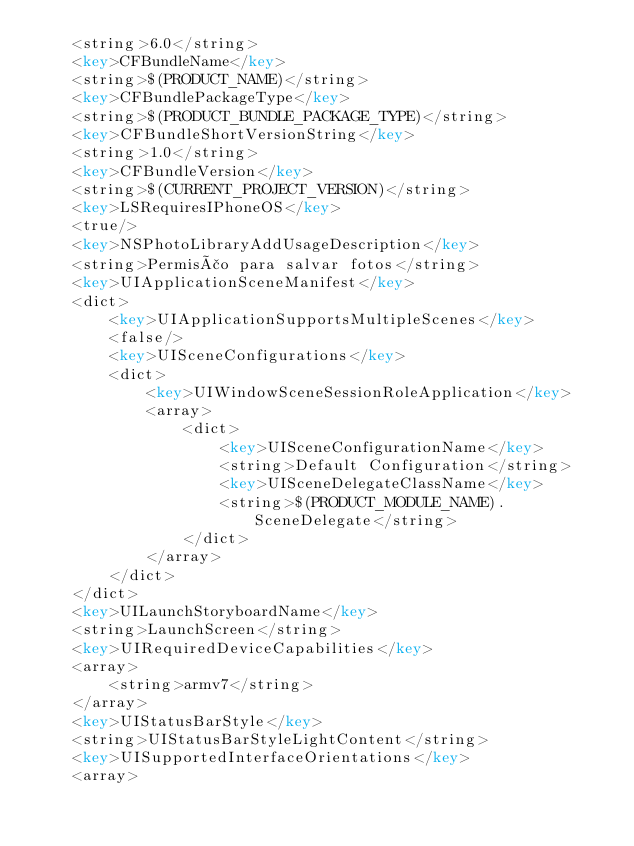<code> <loc_0><loc_0><loc_500><loc_500><_XML_>	<string>6.0</string>
	<key>CFBundleName</key>
	<string>$(PRODUCT_NAME)</string>
	<key>CFBundlePackageType</key>
	<string>$(PRODUCT_BUNDLE_PACKAGE_TYPE)</string>
	<key>CFBundleShortVersionString</key>
	<string>1.0</string>
	<key>CFBundleVersion</key>
	<string>$(CURRENT_PROJECT_VERSION)</string>
	<key>LSRequiresIPhoneOS</key>
	<true/>
	<key>NSPhotoLibraryAddUsageDescription</key>
	<string>Permisão para salvar fotos</string>
	<key>UIApplicationSceneManifest</key>
	<dict>
		<key>UIApplicationSupportsMultipleScenes</key>
		<false/>
		<key>UISceneConfigurations</key>
		<dict>
			<key>UIWindowSceneSessionRoleApplication</key>
			<array>
				<dict>
					<key>UISceneConfigurationName</key>
					<string>Default Configuration</string>
					<key>UISceneDelegateClassName</key>
					<string>$(PRODUCT_MODULE_NAME).SceneDelegate</string>
				</dict>
			</array>
		</dict>
	</dict>
	<key>UILaunchStoryboardName</key>
	<string>LaunchScreen</string>
	<key>UIRequiredDeviceCapabilities</key>
	<array>
		<string>armv7</string>
	</array>
	<key>UIStatusBarStyle</key>
	<string>UIStatusBarStyleLightContent</string>
	<key>UISupportedInterfaceOrientations</key>
	<array></code> 